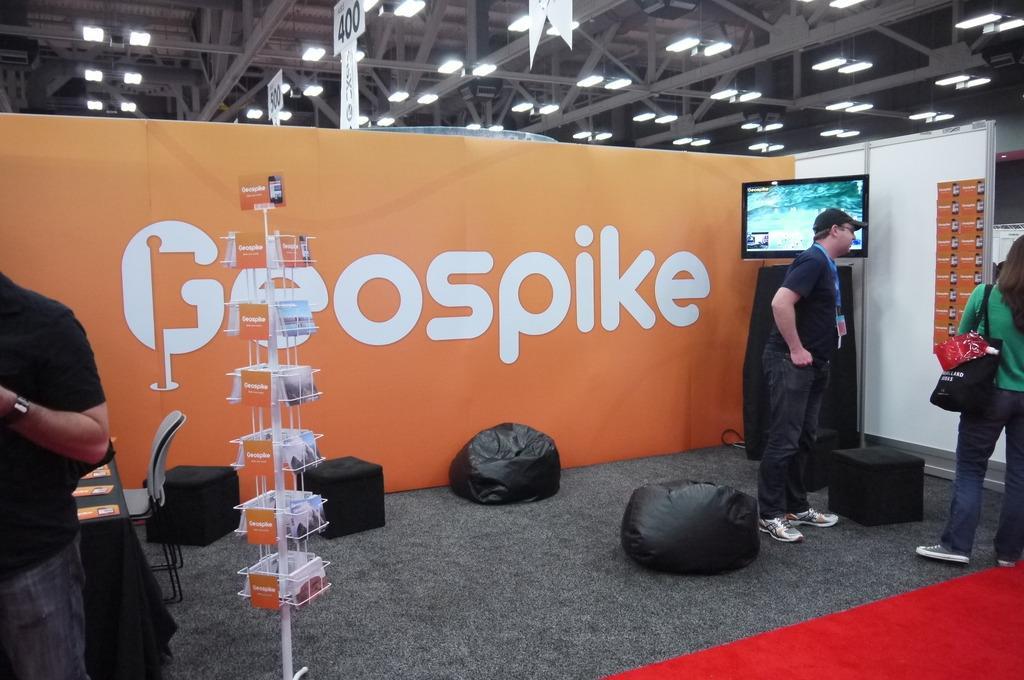Can you describe this image briefly? In this picture we can see three people on the ground, woman is wearing bags, here we can see a television, bean bags, stools, chair, table, on this table we can see posters, here we can see a stand with name cards, banner, wall, name boards, lights, rods, roof and some objects. 